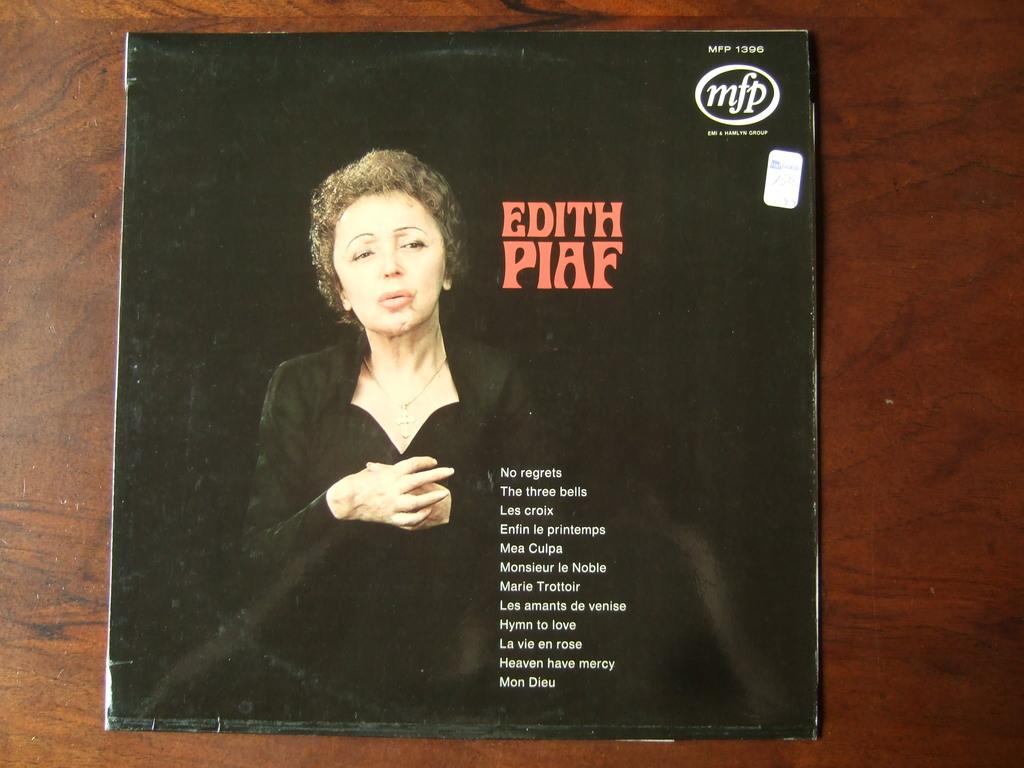What is the main subject of the image? There is a photo of a woman in the image. What else can be seen in the image besides the photo of the woman? There is a pamphlet with words, a logo, numbers, and a sticker on it. Where is the pamphlet located in the image? The pamphlet is on a wooden board. What type of mine is depicted in the image? There is no mine present in the image; it features a photo of a woman and a pamphlet on a wooden board. Can you compare the size of the celery to the woman in the image? There is no celery present in the image, so it cannot be compared to the woman. 